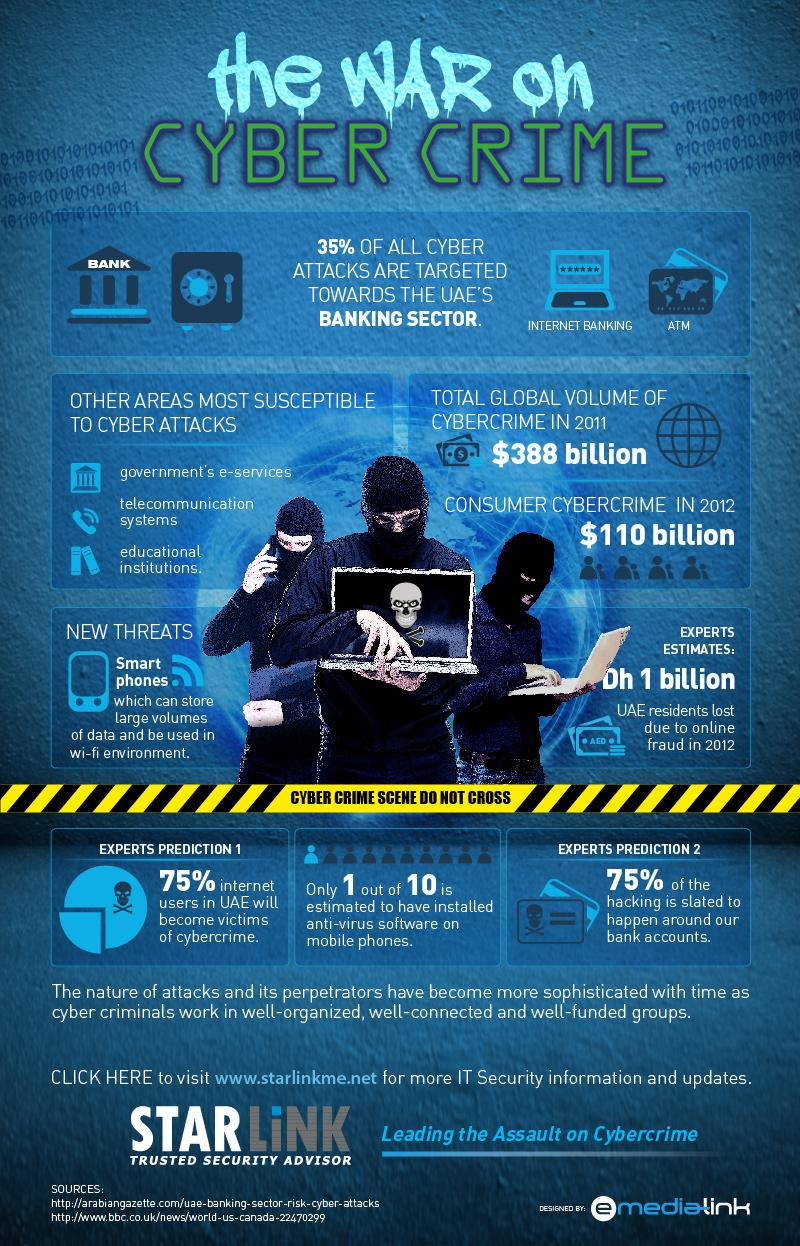Highlight a few significant elements in this photo. According to experts in 2012, UAE residents incurred an estimated loss of Dh 1 billion due to online fraud. According to a report in 2012, the volume of consumer cybercrime was estimated to be $110 billion. According to expert predictions, only 25% of internet users in the UAE are likely to become victims of cybercrime. 